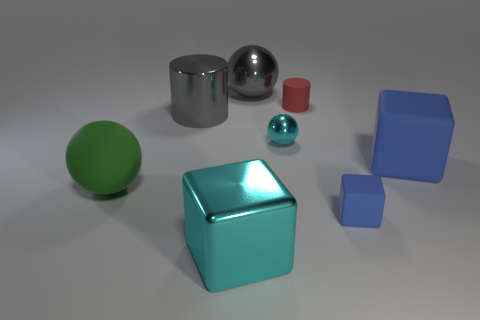What number of things are blue things that are behind the green thing or cubes that are in front of the large blue cube?
Offer a terse response. 3. There is a sphere that is on the left side of the gray metal thing behind the large gray cylinder; what number of large green balls are left of it?
Ensure brevity in your answer.  0. What size is the gray shiny object that is in front of the tiny red cylinder?
Ensure brevity in your answer.  Large. How many objects are the same size as the shiny cylinder?
Ensure brevity in your answer.  4. Do the green matte sphere and the cyan metallic object that is behind the large blue matte thing have the same size?
Provide a succinct answer. No. How many objects are either tiny red things or tiny balls?
Offer a terse response. 2. What number of balls have the same color as the large shiny cylinder?
Your answer should be very brief. 1. There is a blue rubber object that is the same size as the red thing; what shape is it?
Your answer should be very brief. Cube. Are there any gray things of the same shape as the big cyan object?
Offer a very short reply. No. What number of cubes are made of the same material as the cyan sphere?
Make the answer very short. 1. 